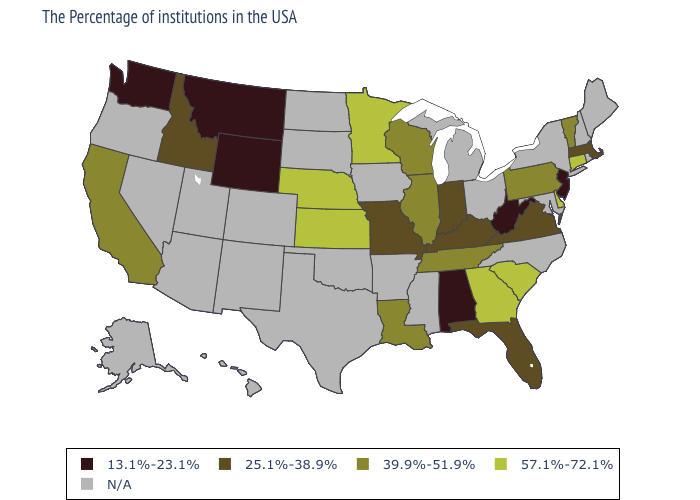What is the value of Minnesota?
Be succinct. 57.1%-72.1%. What is the value of Wyoming?
Answer briefly. 13.1%-23.1%. Which states have the lowest value in the USA?
Give a very brief answer. New Jersey, West Virginia, Alabama, Wyoming, Montana, Washington. Name the states that have a value in the range 39.9%-51.9%?
Short answer required. Vermont, Pennsylvania, Tennessee, Wisconsin, Illinois, Louisiana, California. What is the highest value in states that border Florida?
Give a very brief answer. 57.1%-72.1%. What is the value of Michigan?
Answer briefly. N/A. What is the lowest value in the USA?
Be succinct. 13.1%-23.1%. Among the states that border North Carolina , which have the highest value?
Write a very short answer. South Carolina, Georgia. What is the highest value in the USA?
Be succinct. 57.1%-72.1%. Does the first symbol in the legend represent the smallest category?
Give a very brief answer. Yes. Which states have the lowest value in the USA?
Short answer required. New Jersey, West Virginia, Alabama, Wyoming, Montana, Washington. What is the value of Rhode Island?
Answer briefly. N/A. 